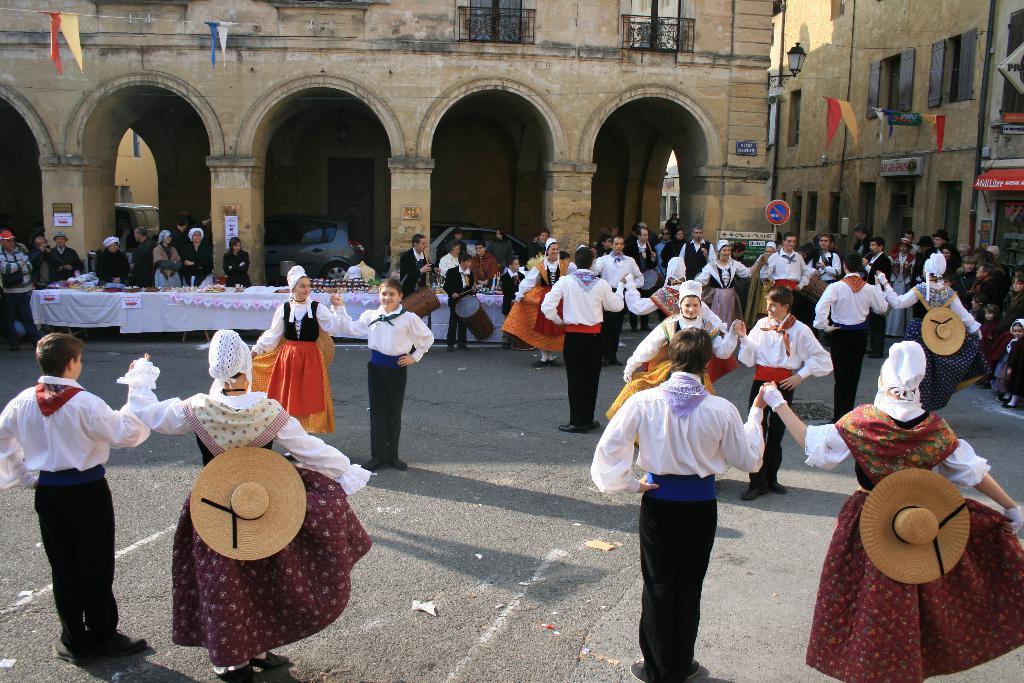Could you give a brief overview of what you see in this image? At the bottom of the image we can see people wearing costumes and dancing. In the background there is a sign board, tables, people, buildings and cars. 